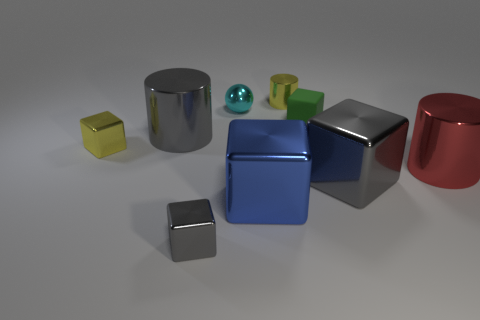How many other objects are the same color as the matte object?
Offer a very short reply. 0. How many metallic objects have the same shape as the green rubber object?
Offer a terse response. 4. What size is the yellow block that is made of the same material as the cyan object?
Ensure brevity in your answer.  Small. How many gray metallic things have the same size as the cyan shiny thing?
Provide a short and direct response. 1. The metal thing that is the same color as the small cylinder is what size?
Offer a terse response. Small. What color is the small metallic thing that is to the left of the big shiny object left of the small shiny sphere?
Offer a terse response. Yellow. Is there a small metal object of the same color as the small metal cylinder?
Your answer should be compact. Yes. The rubber thing that is the same size as the cyan shiny sphere is what color?
Your answer should be compact. Green. Is the large blue object that is in front of the tiny rubber thing made of the same material as the big red cylinder?
Keep it short and to the point. Yes. Are there any large shiny cylinders that are behind the tiny object that is in front of the big gray thing that is right of the small metal sphere?
Provide a succinct answer. Yes. 